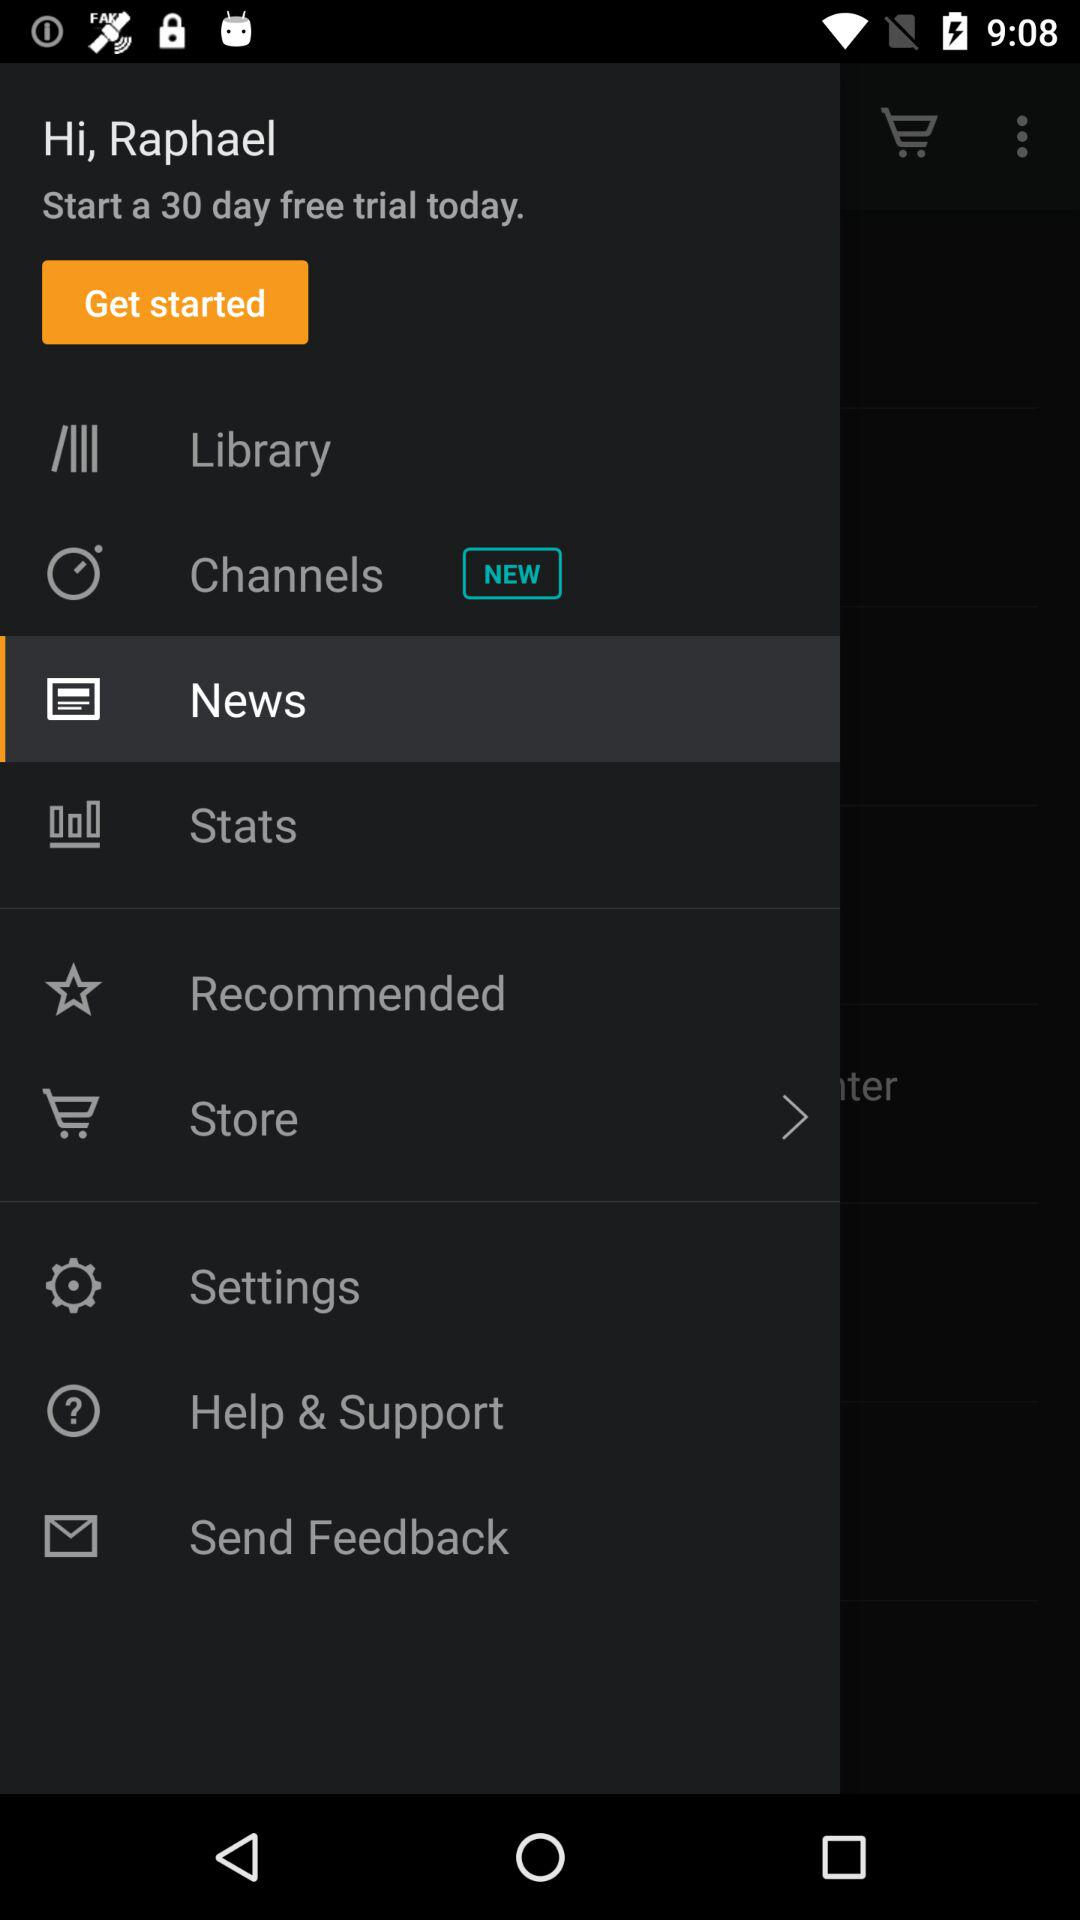What is the name of the user? The name of the user is Raphael. 